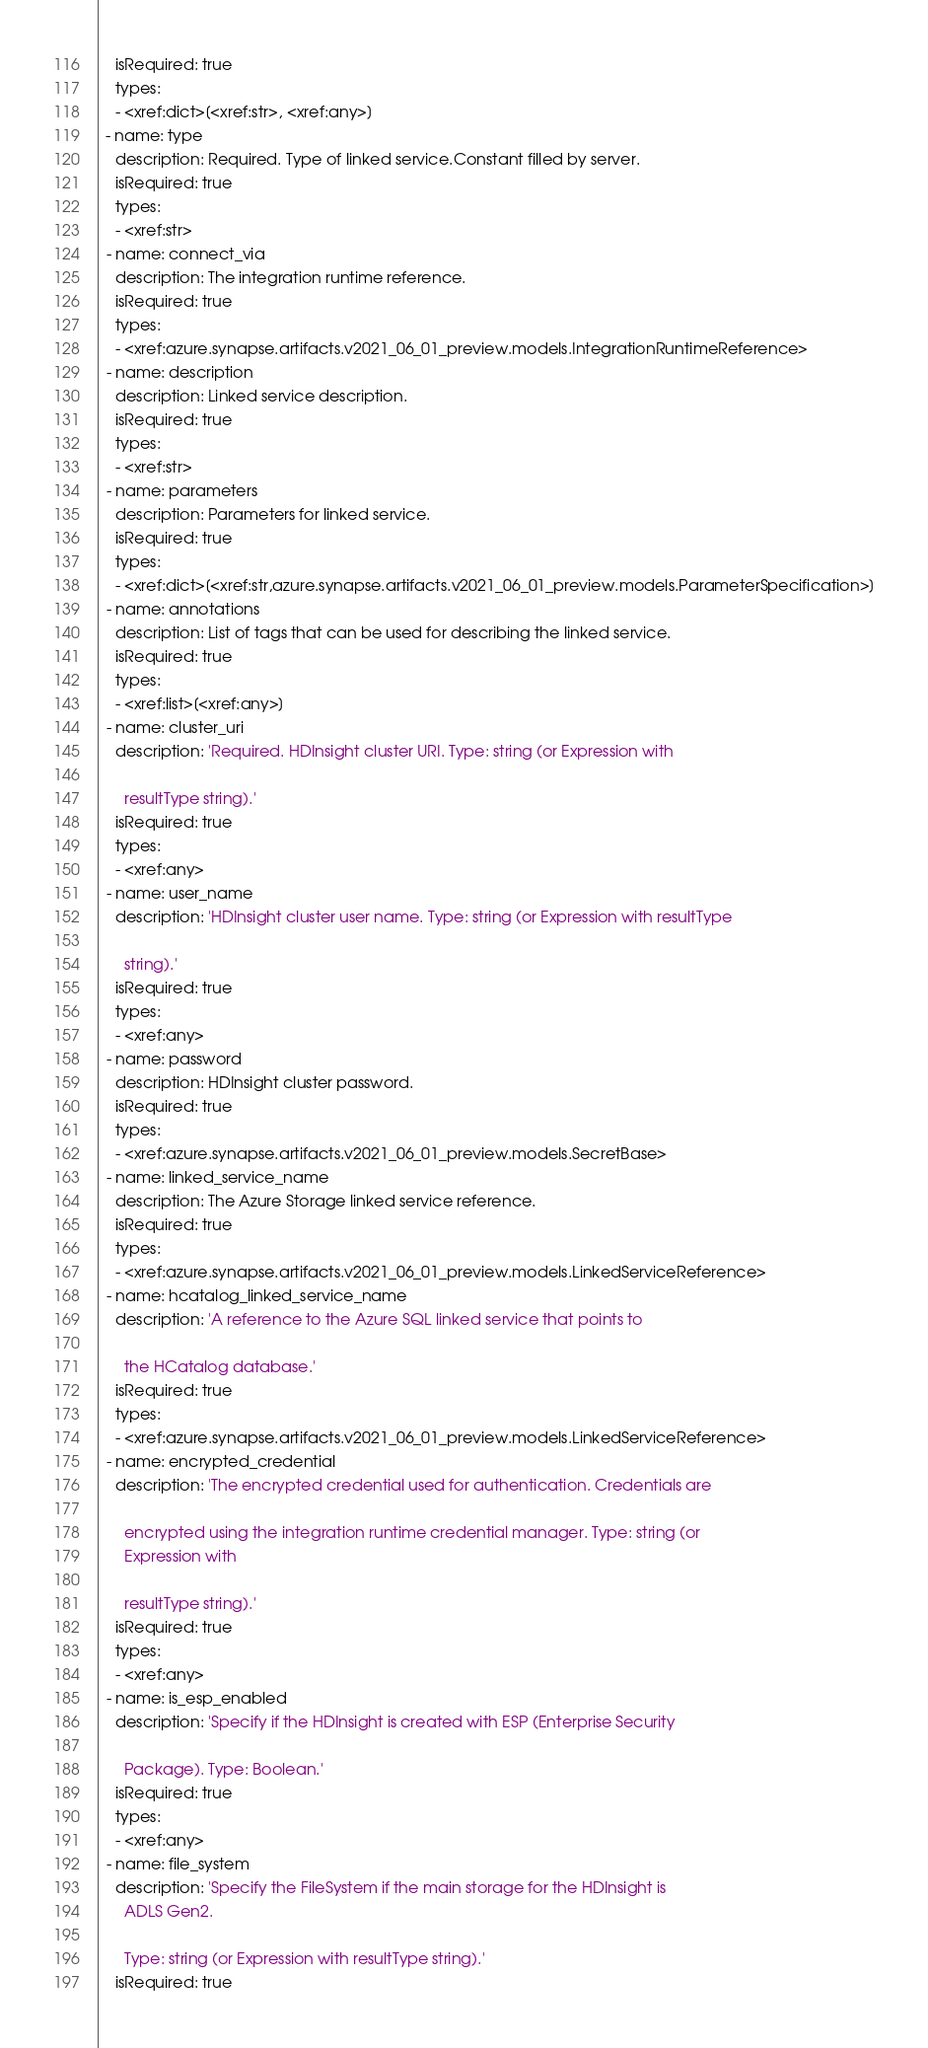<code> <loc_0><loc_0><loc_500><loc_500><_YAML_>    isRequired: true
    types:
    - <xref:dict>[<xref:str>, <xref:any>]
  - name: type
    description: Required. Type of linked service.Constant filled by server.
    isRequired: true
    types:
    - <xref:str>
  - name: connect_via
    description: The integration runtime reference.
    isRequired: true
    types:
    - <xref:azure.synapse.artifacts.v2021_06_01_preview.models.IntegrationRuntimeReference>
  - name: description
    description: Linked service description.
    isRequired: true
    types:
    - <xref:str>
  - name: parameters
    description: Parameters for linked service.
    isRequired: true
    types:
    - <xref:dict>[<xref:str,azure.synapse.artifacts.v2021_06_01_preview.models.ParameterSpecification>]
  - name: annotations
    description: List of tags that can be used for describing the linked service.
    isRequired: true
    types:
    - <xref:list>[<xref:any>]
  - name: cluster_uri
    description: 'Required. HDInsight cluster URI. Type: string (or Expression with

      resultType string).'
    isRequired: true
    types:
    - <xref:any>
  - name: user_name
    description: 'HDInsight cluster user name. Type: string (or Expression with resultType

      string).'
    isRequired: true
    types:
    - <xref:any>
  - name: password
    description: HDInsight cluster password.
    isRequired: true
    types:
    - <xref:azure.synapse.artifacts.v2021_06_01_preview.models.SecretBase>
  - name: linked_service_name
    description: The Azure Storage linked service reference.
    isRequired: true
    types:
    - <xref:azure.synapse.artifacts.v2021_06_01_preview.models.LinkedServiceReference>
  - name: hcatalog_linked_service_name
    description: 'A reference to the Azure SQL linked service that points to

      the HCatalog database.'
    isRequired: true
    types:
    - <xref:azure.synapse.artifacts.v2021_06_01_preview.models.LinkedServiceReference>
  - name: encrypted_credential
    description: 'The encrypted credential used for authentication. Credentials are

      encrypted using the integration runtime credential manager. Type: string (or
      Expression with

      resultType string).'
    isRequired: true
    types:
    - <xref:any>
  - name: is_esp_enabled
    description: 'Specify if the HDInsight is created with ESP (Enterprise Security

      Package). Type: Boolean.'
    isRequired: true
    types:
    - <xref:any>
  - name: file_system
    description: 'Specify the FileSystem if the main storage for the HDInsight is
      ADLS Gen2.

      Type: string (or Expression with resultType string).'
    isRequired: true</code> 